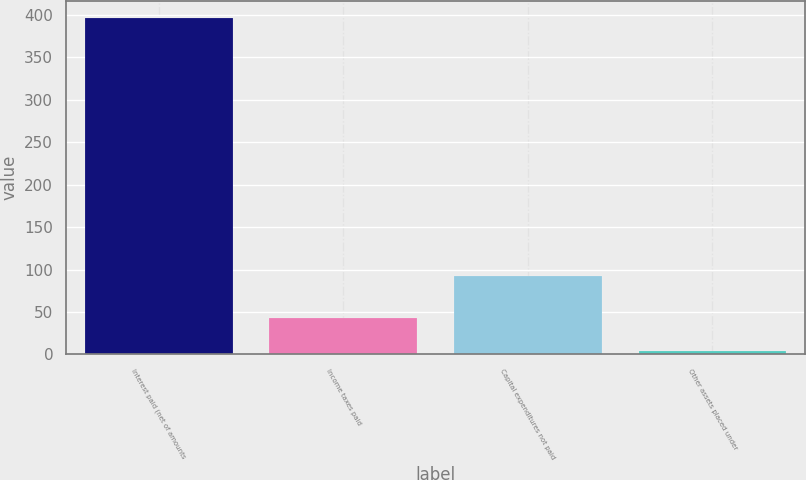Convert chart to OTSL. <chart><loc_0><loc_0><loc_500><loc_500><bar_chart><fcel>Interest paid (net of amounts<fcel>Income taxes paid<fcel>Capital expenditures not paid<fcel>Other assets placed under<nl><fcel>397<fcel>43.3<fcel>92<fcel>4<nl></chart> 